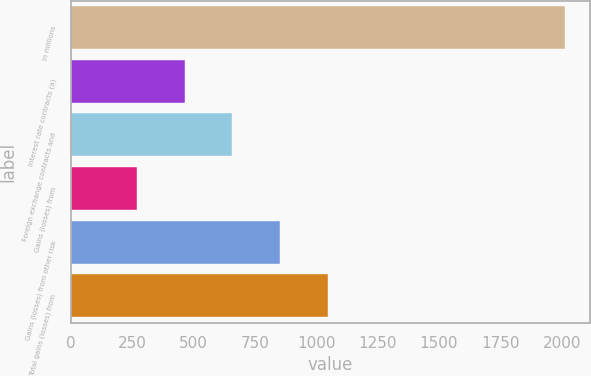Convert chart to OTSL. <chart><loc_0><loc_0><loc_500><loc_500><bar_chart><fcel>In millions<fcel>Interest rate contracts (a)<fcel>Foreign exchange contracts and<fcel>Gains (losses) from<fcel>Gains (losses) from other risk<fcel>Total gains (losses) from<nl><fcel>2015<fcel>465.4<fcel>659.1<fcel>271.7<fcel>852.8<fcel>1046.5<nl></chart> 